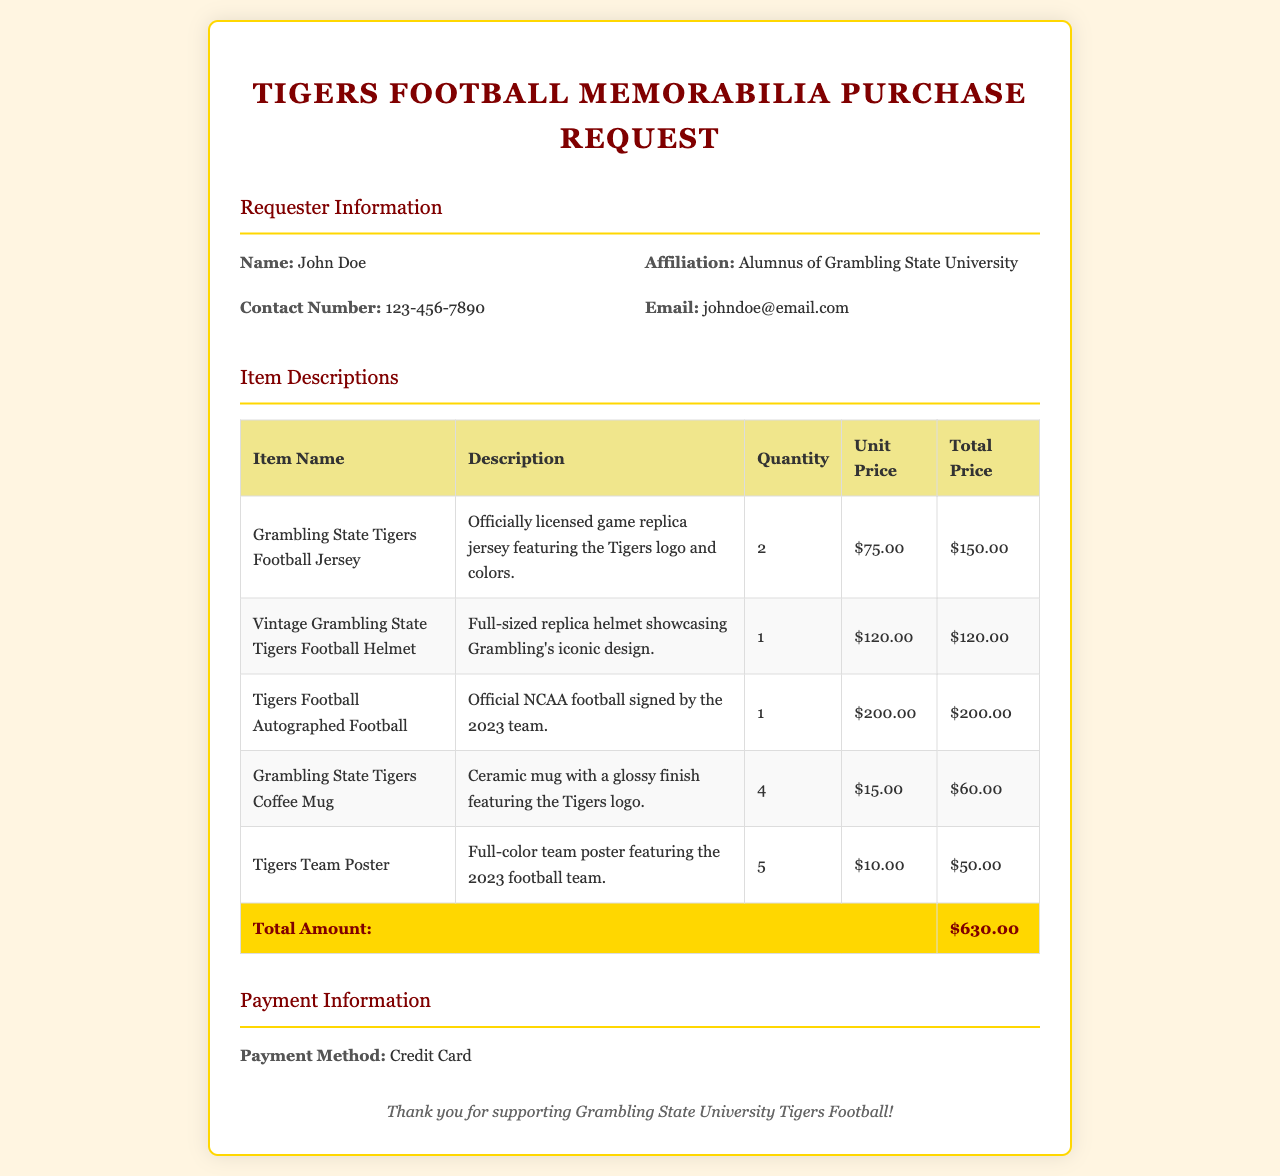What is the requester's name? The requester's name is mentioned in the requester information section of the document.
Answer: John Doe How many Grambling State Tigers Football Jerseys were requested? The document states the quantity requested for each item in the item descriptions section.
Answer: 2 What is the unit price of the Vintage Grambling State Tigers Football Helmet? The unit price is specified for each item in the table under unit price.
Answer: $120.00 What is the total amount for the order? The total amount is calculated and shown at the bottom of the item descriptions table.
Answer: $630.00 How many Tigers Team Posters are included in the request? The quantity for each item is listed in the table under quantity.
Answer: 5 Who signed the Autographed Football? The description of the item mentions who signed it, requiring understanding of the document content.
Answer: 2023 team What payment method was selected for the purchase? The payment method is explicitly mentioned in the payment information section of the document.
Answer: Credit Card What color is the Tigers Coffee Mug? The document describes the mug, indicating its color and finish.
Answer: Glossy What is the affiliation of the requester? The affiliation is provided in the requester information section.
Answer: Alumnus of Grambling State University 